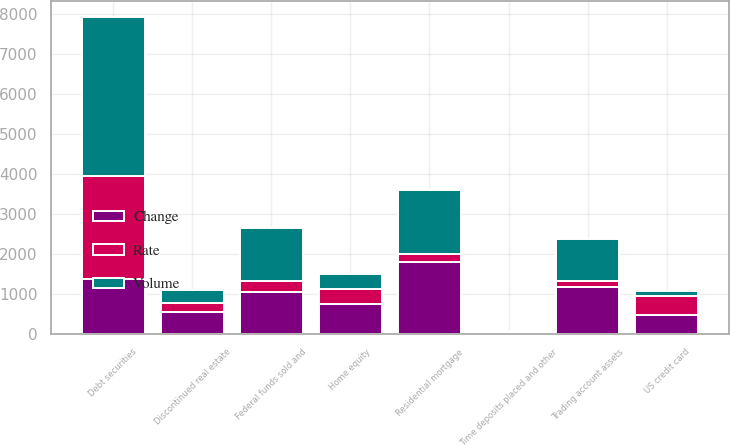Convert chart to OTSL. <chart><loc_0><loc_0><loc_500><loc_500><stacked_bar_chart><ecel><fcel>Time deposits placed and other<fcel>Federal funds sold and<fcel>Trading account assets<fcel>Debt securities<fcel>Residential mortgage<fcel>Home equity<fcel>Discontinued real estate<fcel>US credit card<nl><fcel>Rate<fcel>1<fcel>266<fcel>135<fcel>2585<fcel>192<fcel>391<fcel>219<fcel>473<nl><fcel>Volume<fcel>43<fcel>1328<fcel>1051<fcel>3959<fcel>1607<fcel>355<fcel>336<fcel>119<nl><fcel>Change<fcel>42<fcel>1062<fcel>1186<fcel>1374<fcel>1799<fcel>746<fcel>555<fcel>473<nl></chart> 